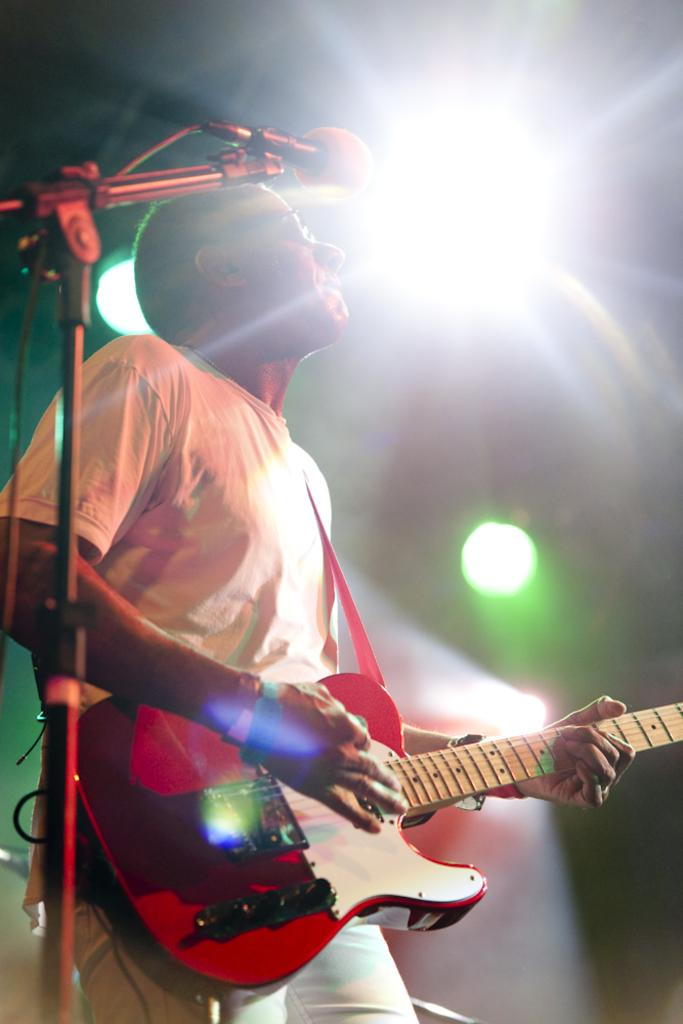What is the main subject of the image? There is a person in the image. What is the person doing in the image? The person is standing and playing a musical instrument. What is the person wearing in the image? The person is wearing a white shirt. What other objects can be seen in the image? There is a microphone and a light in the image. Can you describe the light in the background? The light in the background is green in color. How many dolls are sitting on the paper in the image? There are no dolls or paper present in the image. What type of pen is the person holding while playing the musical instrument? The person is not holding a pen in the image; they are playing a musical instrument. 